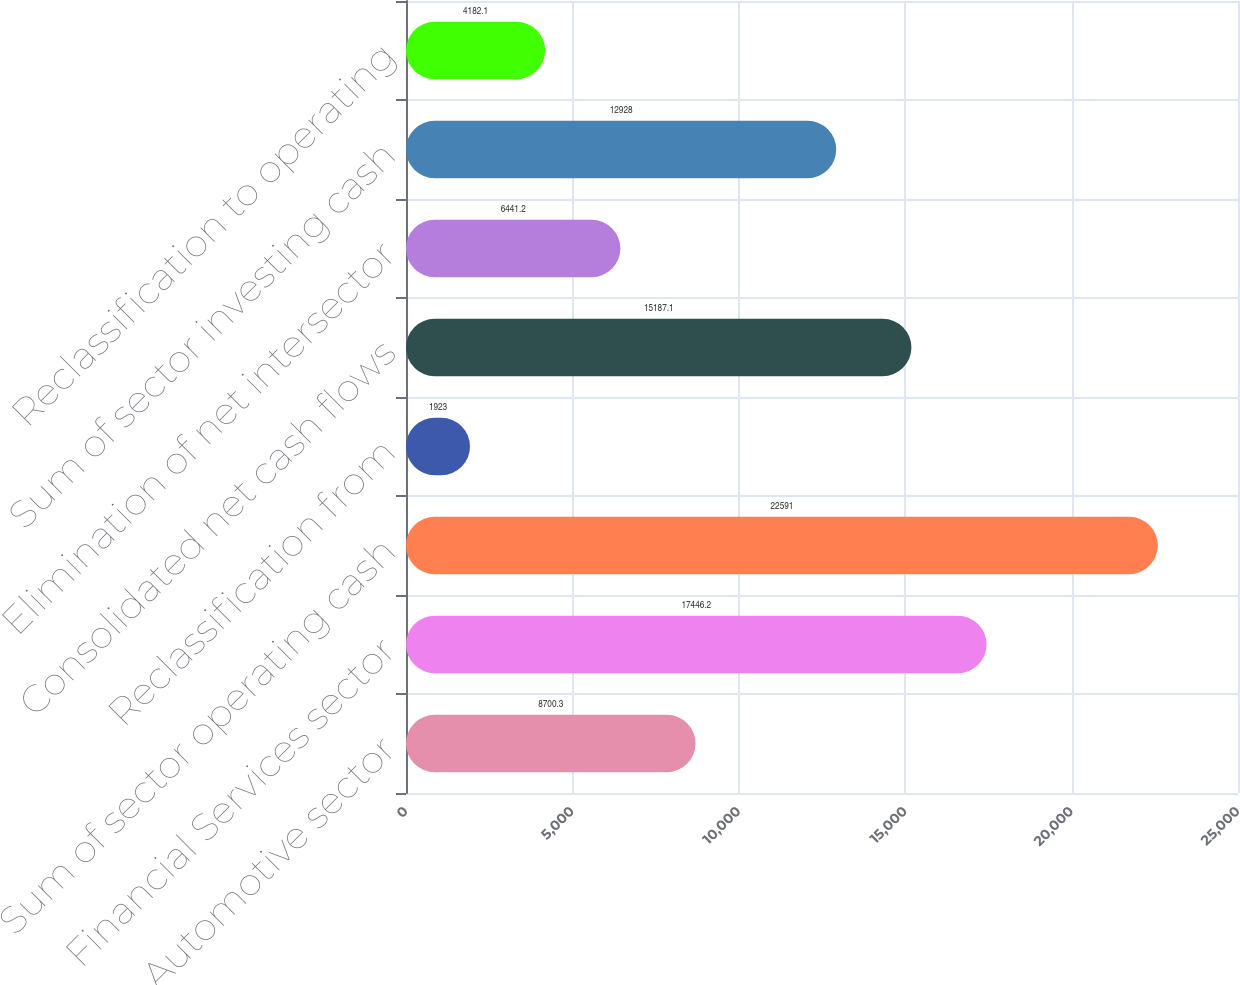Convert chart to OTSL. <chart><loc_0><loc_0><loc_500><loc_500><bar_chart><fcel>Automotive sector<fcel>Financial Services sector<fcel>Sum of sector operating cash<fcel>Reclassification from<fcel>Consolidated net cash flows<fcel>Elimination of net intersector<fcel>Sum of sector investing cash<fcel>Reclassification to operating<nl><fcel>8700.3<fcel>17446.2<fcel>22591<fcel>1923<fcel>15187.1<fcel>6441.2<fcel>12928<fcel>4182.1<nl></chart> 